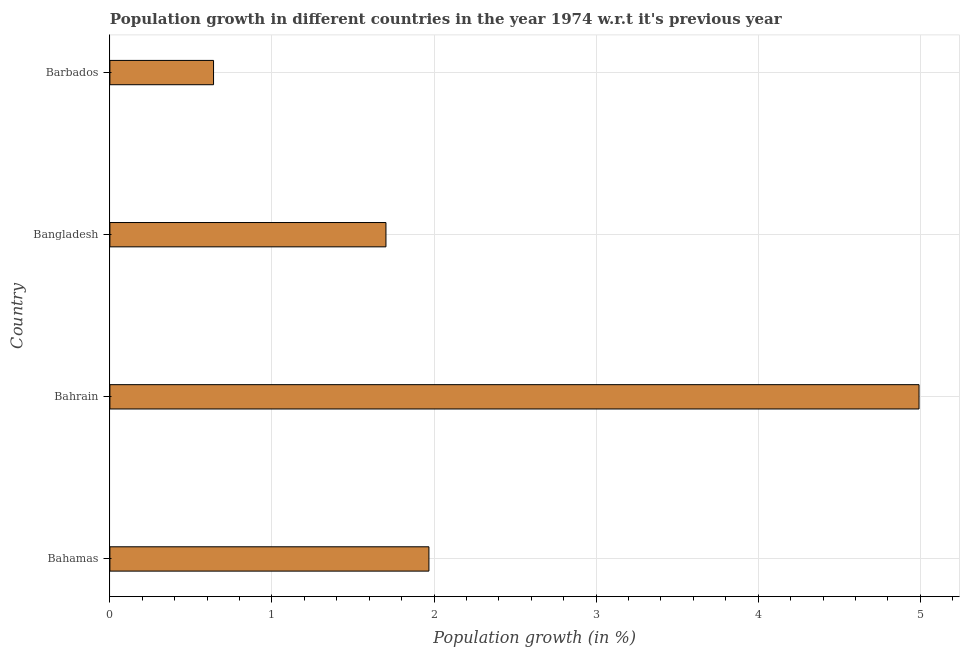Does the graph contain any zero values?
Make the answer very short. No. What is the title of the graph?
Keep it short and to the point. Population growth in different countries in the year 1974 w.r.t it's previous year. What is the label or title of the X-axis?
Offer a terse response. Population growth (in %). What is the label or title of the Y-axis?
Provide a short and direct response. Country. What is the population growth in Bahamas?
Make the answer very short. 1.97. Across all countries, what is the maximum population growth?
Your response must be concise. 4.99. Across all countries, what is the minimum population growth?
Your response must be concise. 0.64. In which country was the population growth maximum?
Offer a very short reply. Bahrain. In which country was the population growth minimum?
Your answer should be compact. Barbados. What is the sum of the population growth?
Provide a succinct answer. 9.3. What is the difference between the population growth in Bangladesh and Barbados?
Ensure brevity in your answer.  1.06. What is the average population growth per country?
Your answer should be compact. 2.33. What is the median population growth?
Provide a succinct answer. 1.84. In how many countries, is the population growth greater than 2.2 %?
Offer a very short reply. 1. What is the ratio of the population growth in Bahamas to that in Barbados?
Offer a very short reply. 3.08. Is the population growth in Bahrain less than that in Bangladesh?
Provide a succinct answer. No. Is the difference between the population growth in Bahamas and Bahrain greater than the difference between any two countries?
Your response must be concise. No. What is the difference between the highest and the second highest population growth?
Keep it short and to the point. 3.02. What is the difference between the highest and the lowest population growth?
Keep it short and to the point. 4.35. In how many countries, is the population growth greater than the average population growth taken over all countries?
Offer a very short reply. 1. How many bars are there?
Provide a succinct answer. 4. Are all the bars in the graph horizontal?
Offer a terse response. Yes. How many countries are there in the graph?
Make the answer very short. 4. What is the difference between two consecutive major ticks on the X-axis?
Your answer should be compact. 1. What is the Population growth (in %) of Bahamas?
Your answer should be compact. 1.97. What is the Population growth (in %) of Bahrain?
Provide a succinct answer. 4.99. What is the Population growth (in %) in Bangladesh?
Make the answer very short. 1.7. What is the Population growth (in %) in Barbados?
Your answer should be very brief. 0.64. What is the difference between the Population growth (in %) in Bahamas and Bahrain?
Give a very brief answer. -3.02. What is the difference between the Population growth (in %) in Bahamas and Bangladesh?
Make the answer very short. 0.27. What is the difference between the Population growth (in %) in Bahamas and Barbados?
Make the answer very short. 1.33. What is the difference between the Population growth (in %) in Bahrain and Bangladesh?
Keep it short and to the point. 3.29. What is the difference between the Population growth (in %) in Bahrain and Barbados?
Keep it short and to the point. 4.35. What is the difference between the Population growth (in %) in Bangladesh and Barbados?
Provide a short and direct response. 1.06. What is the ratio of the Population growth (in %) in Bahamas to that in Bahrain?
Your answer should be very brief. 0.39. What is the ratio of the Population growth (in %) in Bahamas to that in Bangladesh?
Offer a very short reply. 1.16. What is the ratio of the Population growth (in %) in Bahamas to that in Barbados?
Keep it short and to the point. 3.08. What is the ratio of the Population growth (in %) in Bahrain to that in Bangladesh?
Offer a very short reply. 2.93. What is the ratio of the Population growth (in %) in Bahrain to that in Barbados?
Provide a short and direct response. 7.81. What is the ratio of the Population growth (in %) in Bangladesh to that in Barbados?
Keep it short and to the point. 2.66. 